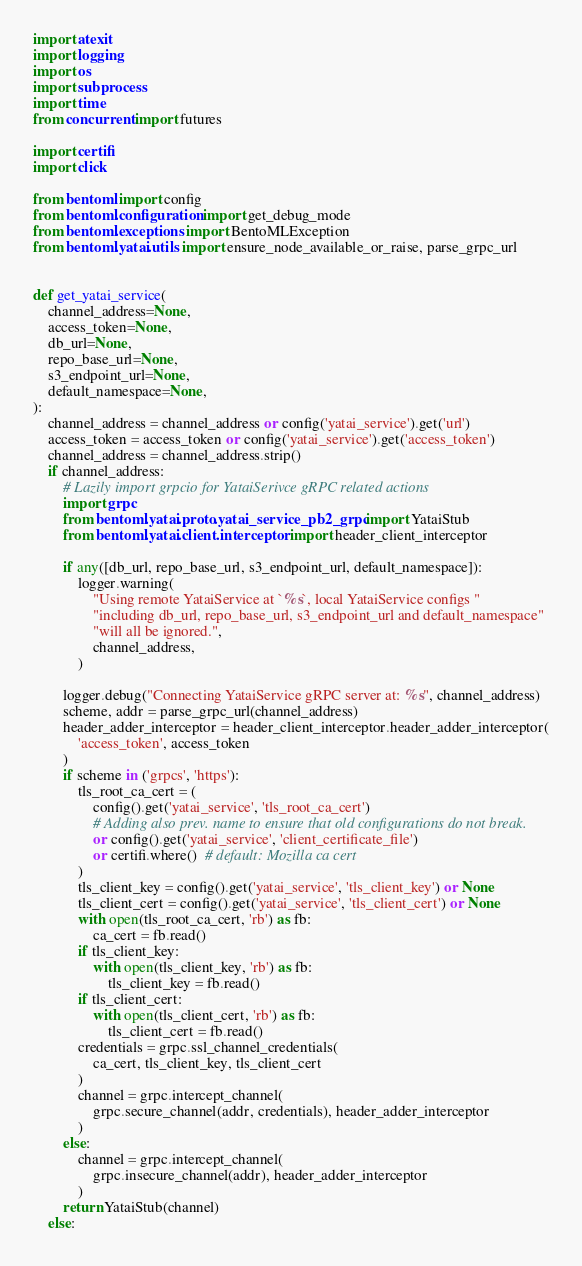Convert code to text. <code><loc_0><loc_0><loc_500><loc_500><_Python_>import atexit
import logging
import os
import subprocess
import time
from concurrent import futures

import certifi
import click

from bentoml import config
from bentoml.configuration import get_debug_mode
from bentoml.exceptions import BentoMLException
from bentoml.yatai.utils import ensure_node_available_or_raise, parse_grpc_url


def get_yatai_service(
    channel_address=None,
    access_token=None,
    db_url=None,
    repo_base_url=None,
    s3_endpoint_url=None,
    default_namespace=None,
):
    channel_address = channel_address or config('yatai_service').get('url')
    access_token = access_token or config('yatai_service').get('access_token')
    channel_address = channel_address.strip()
    if channel_address:
        # Lazily import grpcio for YataiSerivce gRPC related actions
        import grpc
        from bentoml.yatai.proto.yatai_service_pb2_grpc import YataiStub
        from bentoml.yatai.client.interceptor import header_client_interceptor

        if any([db_url, repo_base_url, s3_endpoint_url, default_namespace]):
            logger.warning(
                "Using remote YataiService at `%s`, local YataiService configs "
                "including db_url, repo_base_url, s3_endpoint_url and default_namespace"
                "will all be ignored.",
                channel_address,
            )

        logger.debug("Connecting YataiService gRPC server at: %s", channel_address)
        scheme, addr = parse_grpc_url(channel_address)
        header_adder_interceptor = header_client_interceptor.header_adder_interceptor(
            'access_token', access_token
        )
        if scheme in ('grpcs', 'https'):
            tls_root_ca_cert = (
                config().get('yatai_service', 'tls_root_ca_cert')
                # Adding also prev. name to ensure that old configurations do not break.
                or config().get('yatai_service', 'client_certificate_file')
                or certifi.where()  # default: Mozilla ca cert
            )
            tls_client_key = config().get('yatai_service', 'tls_client_key') or None
            tls_client_cert = config().get('yatai_service', 'tls_client_cert') or None
            with open(tls_root_ca_cert, 'rb') as fb:
                ca_cert = fb.read()
            if tls_client_key:
                with open(tls_client_key, 'rb') as fb:
                    tls_client_key = fb.read()
            if tls_client_cert:
                with open(tls_client_cert, 'rb') as fb:
                    tls_client_cert = fb.read()
            credentials = grpc.ssl_channel_credentials(
                ca_cert, tls_client_key, tls_client_cert
            )
            channel = grpc.intercept_channel(
                grpc.secure_channel(addr, credentials), header_adder_interceptor
            )
        else:
            channel = grpc.intercept_channel(
                grpc.insecure_channel(addr), header_adder_interceptor
            )
        return YataiStub(channel)
    else:</code> 